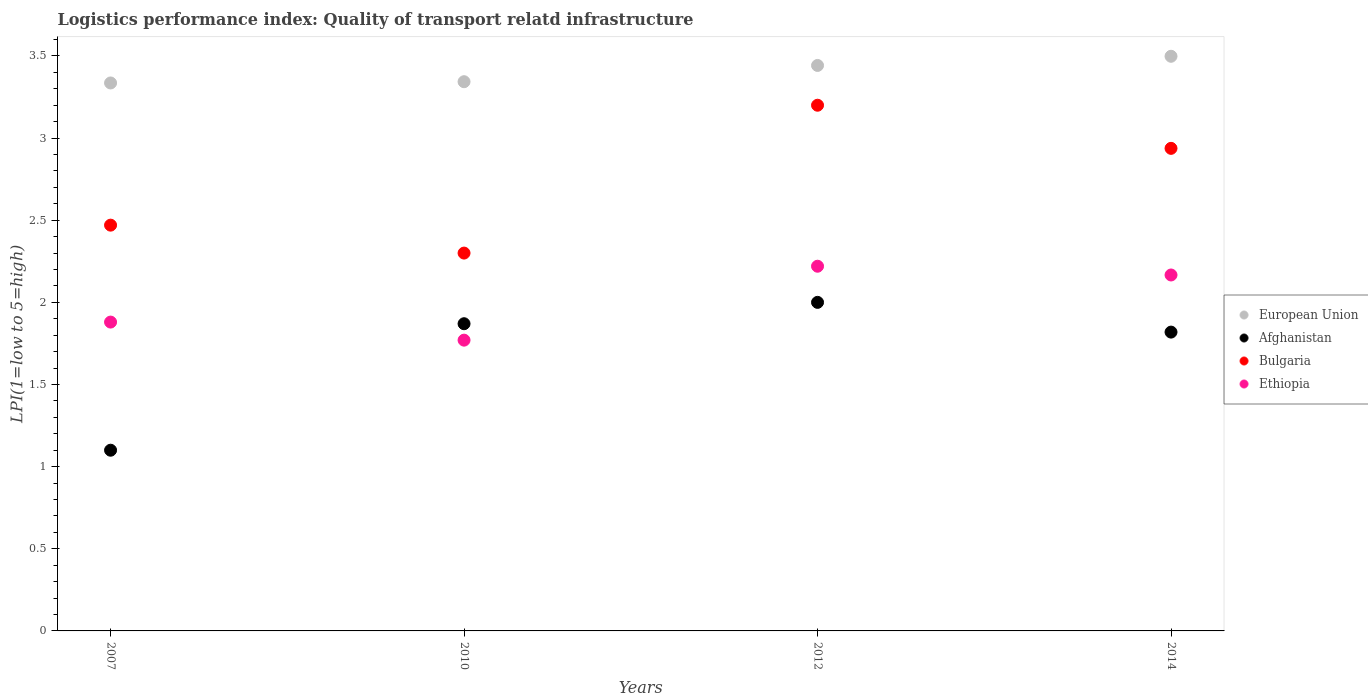What is the logistics performance index in European Union in 2007?
Your answer should be compact. 3.34. Across all years, what is the minimum logistics performance index in European Union?
Provide a short and direct response. 3.34. In which year was the logistics performance index in Afghanistan minimum?
Provide a short and direct response. 2007. What is the total logistics performance index in European Union in the graph?
Give a very brief answer. 13.62. What is the difference between the logistics performance index in European Union in 2007 and that in 2012?
Keep it short and to the point. -0.11. What is the difference between the logistics performance index in Bulgaria in 2014 and the logistics performance index in European Union in 2007?
Offer a terse response. -0.4. What is the average logistics performance index in Afghanistan per year?
Keep it short and to the point. 1.7. In the year 2012, what is the difference between the logistics performance index in European Union and logistics performance index in Afghanistan?
Ensure brevity in your answer.  1.44. What is the ratio of the logistics performance index in Afghanistan in 2007 to that in 2012?
Provide a short and direct response. 0.55. Is the difference between the logistics performance index in European Union in 2007 and 2012 greater than the difference between the logistics performance index in Afghanistan in 2007 and 2012?
Offer a terse response. Yes. What is the difference between the highest and the second highest logistics performance index in Ethiopia?
Make the answer very short. 0.05. What is the difference between the highest and the lowest logistics performance index in European Union?
Offer a very short reply. 0.16. Is it the case that in every year, the sum of the logistics performance index in European Union and logistics performance index in Afghanistan  is greater than the sum of logistics performance index in Ethiopia and logistics performance index in Bulgaria?
Provide a succinct answer. Yes. Does the logistics performance index in Ethiopia monotonically increase over the years?
Ensure brevity in your answer.  No. Is the logistics performance index in Bulgaria strictly less than the logistics performance index in Afghanistan over the years?
Make the answer very short. No. How many dotlines are there?
Provide a short and direct response. 4. How many years are there in the graph?
Offer a very short reply. 4. Are the values on the major ticks of Y-axis written in scientific E-notation?
Offer a very short reply. No. Does the graph contain grids?
Keep it short and to the point. No. Where does the legend appear in the graph?
Provide a short and direct response. Center right. How many legend labels are there?
Keep it short and to the point. 4. How are the legend labels stacked?
Provide a succinct answer. Vertical. What is the title of the graph?
Make the answer very short. Logistics performance index: Quality of transport relatd infrastructure. Does "Nigeria" appear as one of the legend labels in the graph?
Your answer should be compact. No. What is the label or title of the Y-axis?
Provide a succinct answer. LPI(1=low to 5=high). What is the LPI(1=low to 5=high) in European Union in 2007?
Provide a succinct answer. 3.34. What is the LPI(1=low to 5=high) of Afghanistan in 2007?
Your answer should be compact. 1.1. What is the LPI(1=low to 5=high) in Bulgaria in 2007?
Provide a short and direct response. 2.47. What is the LPI(1=low to 5=high) in Ethiopia in 2007?
Ensure brevity in your answer.  1.88. What is the LPI(1=low to 5=high) of European Union in 2010?
Make the answer very short. 3.34. What is the LPI(1=low to 5=high) in Afghanistan in 2010?
Offer a terse response. 1.87. What is the LPI(1=low to 5=high) in Ethiopia in 2010?
Offer a very short reply. 1.77. What is the LPI(1=low to 5=high) of European Union in 2012?
Keep it short and to the point. 3.44. What is the LPI(1=low to 5=high) of Afghanistan in 2012?
Offer a very short reply. 2. What is the LPI(1=low to 5=high) in Bulgaria in 2012?
Provide a short and direct response. 3.2. What is the LPI(1=low to 5=high) of Ethiopia in 2012?
Make the answer very short. 2.22. What is the LPI(1=low to 5=high) in European Union in 2014?
Your answer should be compact. 3.5. What is the LPI(1=low to 5=high) of Afghanistan in 2014?
Make the answer very short. 1.82. What is the LPI(1=low to 5=high) of Bulgaria in 2014?
Offer a terse response. 2.94. What is the LPI(1=low to 5=high) in Ethiopia in 2014?
Provide a short and direct response. 2.17. Across all years, what is the maximum LPI(1=low to 5=high) in European Union?
Provide a succinct answer. 3.5. Across all years, what is the maximum LPI(1=low to 5=high) in Ethiopia?
Keep it short and to the point. 2.22. Across all years, what is the minimum LPI(1=low to 5=high) of European Union?
Offer a terse response. 3.34. Across all years, what is the minimum LPI(1=low to 5=high) of Afghanistan?
Keep it short and to the point. 1.1. Across all years, what is the minimum LPI(1=low to 5=high) of Ethiopia?
Provide a short and direct response. 1.77. What is the total LPI(1=low to 5=high) in European Union in the graph?
Give a very brief answer. 13.62. What is the total LPI(1=low to 5=high) in Afghanistan in the graph?
Keep it short and to the point. 6.79. What is the total LPI(1=low to 5=high) of Bulgaria in the graph?
Ensure brevity in your answer.  10.91. What is the total LPI(1=low to 5=high) in Ethiopia in the graph?
Keep it short and to the point. 8.04. What is the difference between the LPI(1=low to 5=high) of European Union in 2007 and that in 2010?
Provide a succinct answer. -0.01. What is the difference between the LPI(1=low to 5=high) in Afghanistan in 2007 and that in 2010?
Your response must be concise. -0.77. What is the difference between the LPI(1=low to 5=high) of Bulgaria in 2007 and that in 2010?
Your response must be concise. 0.17. What is the difference between the LPI(1=low to 5=high) of Ethiopia in 2007 and that in 2010?
Your response must be concise. 0.11. What is the difference between the LPI(1=low to 5=high) in European Union in 2007 and that in 2012?
Keep it short and to the point. -0.11. What is the difference between the LPI(1=low to 5=high) of Bulgaria in 2007 and that in 2012?
Provide a succinct answer. -0.73. What is the difference between the LPI(1=low to 5=high) of Ethiopia in 2007 and that in 2012?
Offer a very short reply. -0.34. What is the difference between the LPI(1=low to 5=high) in European Union in 2007 and that in 2014?
Provide a succinct answer. -0.16. What is the difference between the LPI(1=low to 5=high) in Afghanistan in 2007 and that in 2014?
Your answer should be compact. -0.72. What is the difference between the LPI(1=low to 5=high) in Bulgaria in 2007 and that in 2014?
Make the answer very short. -0.47. What is the difference between the LPI(1=low to 5=high) in Ethiopia in 2007 and that in 2014?
Give a very brief answer. -0.29. What is the difference between the LPI(1=low to 5=high) in European Union in 2010 and that in 2012?
Your answer should be very brief. -0.1. What is the difference between the LPI(1=low to 5=high) in Afghanistan in 2010 and that in 2012?
Give a very brief answer. -0.13. What is the difference between the LPI(1=low to 5=high) of Ethiopia in 2010 and that in 2012?
Your response must be concise. -0.45. What is the difference between the LPI(1=low to 5=high) in European Union in 2010 and that in 2014?
Provide a short and direct response. -0.15. What is the difference between the LPI(1=low to 5=high) of Afghanistan in 2010 and that in 2014?
Provide a short and direct response. 0.05. What is the difference between the LPI(1=low to 5=high) in Bulgaria in 2010 and that in 2014?
Ensure brevity in your answer.  -0.64. What is the difference between the LPI(1=low to 5=high) of Ethiopia in 2010 and that in 2014?
Keep it short and to the point. -0.4. What is the difference between the LPI(1=low to 5=high) in European Union in 2012 and that in 2014?
Offer a terse response. -0.06. What is the difference between the LPI(1=low to 5=high) of Afghanistan in 2012 and that in 2014?
Provide a short and direct response. 0.18. What is the difference between the LPI(1=low to 5=high) in Bulgaria in 2012 and that in 2014?
Offer a terse response. 0.26. What is the difference between the LPI(1=low to 5=high) of Ethiopia in 2012 and that in 2014?
Your answer should be very brief. 0.05. What is the difference between the LPI(1=low to 5=high) of European Union in 2007 and the LPI(1=low to 5=high) of Afghanistan in 2010?
Make the answer very short. 1.47. What is the difference between the LPI(1=low to 5=high) of European Union in 2007 and the LPI(1=low to 5=high) of Bulgaria in 2010?
Provide a succinct answer. 1.04. What is the difference between the LPI(1=low to 5=high) in European Union in 2007 and the LPI(1=low to 5=high) in Ethiopia in 2010?
Your answer should be very brief. 1.57. What is the difference between the LPI(1=low to 5=high) of Afghanistan in 2007 and the LPI(1=low to 5=high) of Bulgaria in 2010?
Make the answer very short. -1.2. What is the difference between the LPI(1=low to 5=high) in Afghanistan in 2007 and the LPI(1=low to 5=high) in Ethiopia in 2010?
Give a very brief answer. -0.67. What is the difference between the LPI(1=low to 5=high) in European Union in 2007 and the LPI(1=low to 5=high) in Afghanistan in 2012?
Keep it short and to the point. 1.34. What is the difference between the LPI(1=low to 5=high) in European Union in 2007 and the LPI(1=low to 5=high) in Bulgaria in 2012?
Offer a very short reply. 0.14. What is the difference between the LPI(1=low to 5=high) of European Union in 2007 and the LPI(1=low to 5=high) of Ethiopia in 2012?
Keep it short and to the point. 1.12. What is the difference between the LPI(1=low to 5=high) in Afghanistan in 2007 and the LPI(1=low to 5=high) in Bulgaria in 2012?
Your response must be concise. -2.1. What is the difference between the LPI(1=low to 5=high) in Afghanistan in 2007 and the LPI(1=low to 5=high) in Ethiopia in 2012?
Your answer should be very brief. -1.12. What is the difference between the LPI(1=low to 5=high) in Bulgaria in 2007 and the LPI(1=low to 5=high) in Ethiopia in 2012?
Offer a very short reply. 0.25. What is the difference between the LPI(1=low to 5=high) of European Union in 2007 and the LPI(1=low to 5=high) of Afghanistan in 2014?
Your response must be concise. 1.52. What is the difference between the LPI(1=low to 5=high) of European Union in 2007 and the LPI(1=low to 5=high) of Bulgaria in 2014?
Ensure brevity in your answer.  0.4. What is the difference between the LPI(1=low to 5=high) of European Union in 2007 and the LPI(1=low to 5=high) of Ethiopia in 2014?
Offer a very short reply. 1.17. What is the difference between the LPI(1=low to 5=high) of Afghanistan in 2007 and the LPI(1=low to 5=high) of Bulgaria in 2014?
Provide a succinct answer. -1.84. What is the difference between the LPI(1=low to 5=high) in Afghanistan in 2007 and the LPI(1=low to 5=high) in Ethiopia in 2014?
Your answer should be very brief. -1.07. What is the difference between the LPI(1=low to 5=high) of Bulgaria in 2007 and the LPI(1=low to 5=high) of Ethiopia in 2014?
Offer a very short reply. 0.3. What is the difference between the LPI(1=low to 5=high) of European Union in 2010 and the LPI(1=low to 5=high) of Afghanistan in 2012?
Make the answer very short. 1.34. What is the difference between the LPI(1=low to 5=high) in European Union in 2010 and the LPI(1=low to 5=high) in Bulgaria in 2012?
Make the answer very short. 0.14. What is the difference between the LPI(1=low to 5=high) in European Union in 2010 and the LPI(1=low to 5=high) in Ethiopia in 2012?
Offer a very short reply. 1.12. What is the difference between the LPI(1=low to 5=high) of Afghanistan in 2010 and the LPI(1=low to 5=high) of Bulgaria in 2012?
Make the answer very short. -1.33. What is the difference between the LPI(1=low to 5=high) of Afghanistan in 2010 and the LPI(1=low to 5=high) of Ethiopia in 2012?
Ensure brevity in your answer.  -0.35. What is the difference between the LPI(1=low to 5=high) of Bulgaria in 2010 and the LPI(1=low to 5=high) of Ethiopia in 2012?
Keep it short and to the point. 0.08. What is the difference between the LPI(1=low to 5=high) in European Union in 2010 and the LPI(1=low to 5=high) in Afghanistan in 2014?
Your response must be concise. 1.52. What is the difference between the LPI(1=low to 5=high) in European Union in 2010 and the LPI(1=low to 5=high) in Bulgaria in 2014?
Your answer should be very brief. 0.41. What is the difference between the LPI(1=low to 5=high) in European Union in 2010 and the LPI(1=low to 5=high) in Ethiopia in 2014?
Offer a very short reply. 1.18. What is the difference between the LPI(1=low to 5=high) in Afghanistan in 2010 and the LPI(1=low to 5=high) in Bulgaria in 2014?
Your answer should be compact. -1.07. What is the difference between the LPI(1=low to 5=high) of Afghanistan in 2010 and the LPI(1=low to 5=high) of Ethiopia in 2014?
Your answer should be compact. -0.3. What is the difference between the LPI(1=low to 5=high) in Bulgaria in 2010 and the LPI(1=low to 5=high) in Ethiopia in 2014?
Ensure brevity in your answer.  0.13. What is the difference between the LPI(1=low to 5=high) in European Union in 2012 and the LPI(1=low to 5=high) in Afghanistan in 2014?
Your response must be concise. 1.62. What is the difference between the LPI(1=low to 5=high) in European Union in 2012 and the LPI(1=low to 5=high) in Bulgaria in 2014?
Offer a very short reply. 0.5. What is the difference between the LPI(1=low to 5=high) of European Union in 2012 and the LPI(1=low to 5=high) of Ethiopia in 2014?
Your response must be concise. 1.28. What is the difference between the LPI(1=low to 5=high) in Afghanistan in 2012 and the LPI(1=low to 5=high) in Bulgaria in 2014?
Give a very brief answer. -0.94. What is the difference between the LPI(1=low to 5=high) of Bulgaria in 2012 and the LPI(1=low to 5=high) of Ethiopia in 2014?
Provide a short and direct response. 1.03. What is the average LPI(1=low to 5=high) of European Union per year?
Your response must be concise. 3.4. What is the average LPI(1=low to 5=high) of Afghanistan per year?
Give a very brief answer. 1.7. What is the average LPI(1=low to 5=high) of Bulgaria per year?
Make the answer very short. 2.73. What is the average LPI(1=low to 5=high) in Ethiopia per year?
Provide a short and direct response. 2.01. In the year 2007, what is the difference between the LPI(1=low to 5=high) in European Union and LPI(1=low to 5=high) in Afghanistan?
Give a very brief answer. 2.24. In the year 2007, what is the difference between the LPI(1=low to 5=high) in European Union and LPI(1=low to 5=high) in Bulgaria?
Give a very brief answer. 0.87. In the year 2007, what is the difference between the LPI(1=low to 5=high) in European Union and LPI(1=low to 5=high) in Ethiopia?
Offer a very short reply. 1.46. In the year 2007, what is the difference between the LPI(1=low to 5=high) of Afghanistan and LPI(1=low to 5=high) of Bulgaria?
Your answer should be very brief. -1.37. In the year 2007, what is the difference between the LPI(1=low to 5=high) in Afghanistan and LPI(1=low to 5=high) in Ethiopia?
Offer a terse response. -0.78. In the year 2007, what is the difference between the LPI(1=low to 5=high) in Bulgaria and LPI(1=low to 5=high) in Ethiopia?
Your response must be concise. 0.59. In the year 2010, what is the difference between the LPI(1=low to 5=high) of European Union and LPI(1=low to 5=high) of Afghanistan?
Make the answer very short. 1.47. In the year 2010, what is the difference between the LPI(1=low to 5=high) in European Union and LPI(1=low to 5=high) in Bulgaria?
Make the answer very short. 1.04. In the year 2010, what is the difference between the LPI(1=low to 5=high) of European Union and LPI(1=low to 5=high) of Ethiopia?
Keep it short and to the point. 1.57. In the year 2010, what is the difference between the LPI(1=low to 5=high) in Afghanistan and LPI(1=low to 5=high) in Bulgaria?
Provide a succinct answer. -0.43. In the year 2010, what is the difference between the LPI(1=low to 5=high) in Afghanistan and LPI(1=low to 5=high) in Ethiopia?
Ensure brevity in your answer.  0.1. In the year 2010, what is the difference between the LPI(1=low to 5=high) in Bulgaria and LPI(1=low to 5=high) in Ethiopia?
Make the answer very short. 0.53. In the year 2012, what is the difference between the LPI(1=low to 5=high) in European Union and LPI(1=low to 5=high) in Afghanistan?
Your answer should be compact. 1.44. In the year 2012, what is the difference between the LPI(1=low to 5=high) in European Union and LPI(1=low to 5=high) in Bulgaria?
Offer a terse response. 0.24. In the year 2012, what is the difference between the LPI(1=low to 5=high) of European Union and LPI(1=low to 5=high) of Ethiopia?
Keep it short and to the point. 1.22. In the year 2012, what is the difference between the LPI(1=low to 5=high) of Afghanistan and LPI(1=low to 5=high) of Ethiopia?
Give a very brief answer. -0.22. In the year 2012, what is the difference between the LPI(1=low to 5=high) in Bulgaria and LPI(1=low to 5=high) in Ethiopia?
Your response must be concise. 0.98. In the year 2014, what is the difference between the LPI(1=low to 5=high) of European Union and LPI(1=low to 5=high) of Afghanistan?
Keep it short and to the point. 1.68. In the year 2014, what is the difference between the LPI(1=low to 5=high) of European Union and LPI(1=low to 5=high) of Bulgaria?
Ensure brevity in your answer.  0.56. In the year 2014, what is the difference between the LPI(1=low to 5=high) in European Union and LPI(1=low to 5=high) in Ethiopia?
Offer a very short reply. 1.33. In the year 2014, what is the difference between the LPI(1=low to 5=high) of Afghanistan and LPI(1=low to 5=high) of Bulgaria?
Give a very brief answer. -1.12. In the year 2014, what is the difference between the LPI(1=low to 5=high) of Afghanistan and LPI(1=low to 5=high) of Ethiopia?
Your response must be concise. -0.35. In the year 2014, what is the difference between the LPI(1=low to 5=high) in Bulgaria and LPI(1=low to 5=high) in Ethiopia?
Provide a short and direct response. 0.77. What is the ratio of the LPI(1=low to 5=high) of European Union in 2007 to that in 2010?
Keep it short and to the point. 1. What is the ratio of the LPI(1=low to 5=high) in Afghanistan in 2007 to that in 2010?
Keep it short and to the point. 0.59. What is the ratio of the LPI(1=low to 5=high) in Bulgaria in 2007 to that in 2010?
Keep it short and to the point. 1.07. What is the ratio of the LPI(1=low to 5=high) of Ethiopia in 2007 to that in 2010?
Provide a succinct answer. 1.06. What is the ratio of the LPI(1=low to 5=high) of European Union in 2007 to that in 2012?
Provide a short and direct response. 0.97. What is the ratio of the LPI(1=low to 5=high) in Afghanistan in 2007 to that in 2012?
Your response must be concise. 0.55. What is the ratio of the LPI(1=low to 5=high) of Bulgaria in 2007 to that in 2012?
Ensure brevity in your answer.  0.77. What is the ratio of the LPI(1=low to 5=high) of Ethiopia in 2007 to that in 2012?
Make the answer very short. 0.85. What is the ratio of the LPI(1=low to 5=high) of European Union in 2007 to that in 2014?
Provide a short and direct response. 0.95. What is the ratio of the LPI(1=low to 5=high) in Afghanistan in 2007 to that in 2014?
Provide a succinct answer. 0.6. What is the ratio of the LPI(1=low to 5=high) in Bulgaria in 2007 to that in 2014?
Offer a very short reply. 0.84. What is the ratio of the LPI(1=low to 5=high) in Ethiopia in 2007 to that in 2014?
Your answer should be compact. 0.87. What is the ratio of the LPI(1=low to 5=high) in European Union in 2010 to that in 2012?
Provide a succinct answer. 0.97. What is the ratio of the LPI(1=low to 5=high) of Afghanistan in 2010 to that in 2012?
Make the answer very short. 0.94. What is the ratio of the LPI(1=low to 5=high) of Bulgaria in 2010 to that in 2012?
Provide a succinct answer. 0.72. What is the ratio of the LPI(1=low to 5=high) of Ethiopia in 2010 to that in 2012?
Keep it short and to the point. 0.8. What is the ratio of the LPI(1=low to 5=high) of European Union in 2010 to that in 2014?
Ensure brevity in your answer.  0.96. What is the ratio of the LPI(1=low to 5=high) of Afghanistan in 2010 to that in 2014?
Provide a succinct answer. 1.03. What is the ratio of the LPI(1=low to 5=high) of Bulgaria in 2010 to that in 2014?
Give a very brief answer. 0.78. What is the ratio of the LPI(1=low to 5=high) of Ethiopia in 2010 to that in 2014?
Your answer should be very brief. 0.82. What is the ratio of the LPI(1=low to 5=high) of Afghanistan in 2012 to that in 2014?
Your answer should be very brief. 1.1. What is the ratio of the LPI(1=low to 5=high) in Bulgaria in 2012 to that in 2014?
Your response must be concise. 1.09. What is the ratio of the LPI(1=low to 5=high) in Ethiopia in 2012 to that in 2014?
Your answer should be compact. 1.02. What is the difference between the highest and the second highest LPI(1=low to 5=high) in European Union?
Ensure brevity in your answer.  0.06. What is the difference between the highest and the second highest LPI(1=low to 5=high) of Afghanistan?
Give a very brief answer. 0.13. What is the difference between the highest and the second highest LPI(1=low to 5=high) in Bulgaria?
Your answer should be compact. 0.26. What is the difference between the highest and the second highest LPI(1=low to 5=high) in Ethiopia?
Provide a short and direct response. 0.05. What is the difference between the highest and the lowest LPI(1=low to 5=high) of European Union?
Your response must be concise. 0.16. What is the difference between the highest and the lowest LPI(1=low to 5=high) of Afghanistan?
Make the answer very short. 0.9. What is the difference between the highest and the lowest LPI(1=low to 5=high) in Bulgaria?
Make the answer very short. 0.9. What is the difference between the highest and the lowest LPI(1=low to 5=high) in Ethiopia?
Your answer should be compact. 0.45. 